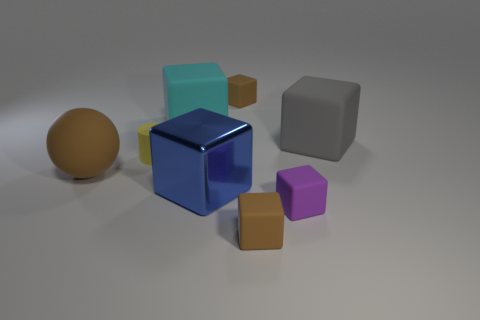Subtract all tiny brown matte cubes. How many cubes are left? 4 Add 2 yellow rubber spheres. How many objects exist? 10 Subtract all blue blocks. How many blocks are left? 5 Subtract all balls. How many objects are left? 7 Subtract 4 blocks. How many blocks are left? 2 Subtract all gray cylinders. How many purple blocks are left? 1 Add 3 small blue shiny blocks. How many small blue shiny blocks exist? 3 Subtract 0 green cylinders. How many objects are left? 8 Subtract all green blocks. Subtract all gray cylinders. How many blocks are left? 6 Subtract all large cyan things. Subtract all large blue cubes. How many objects are left? 6 